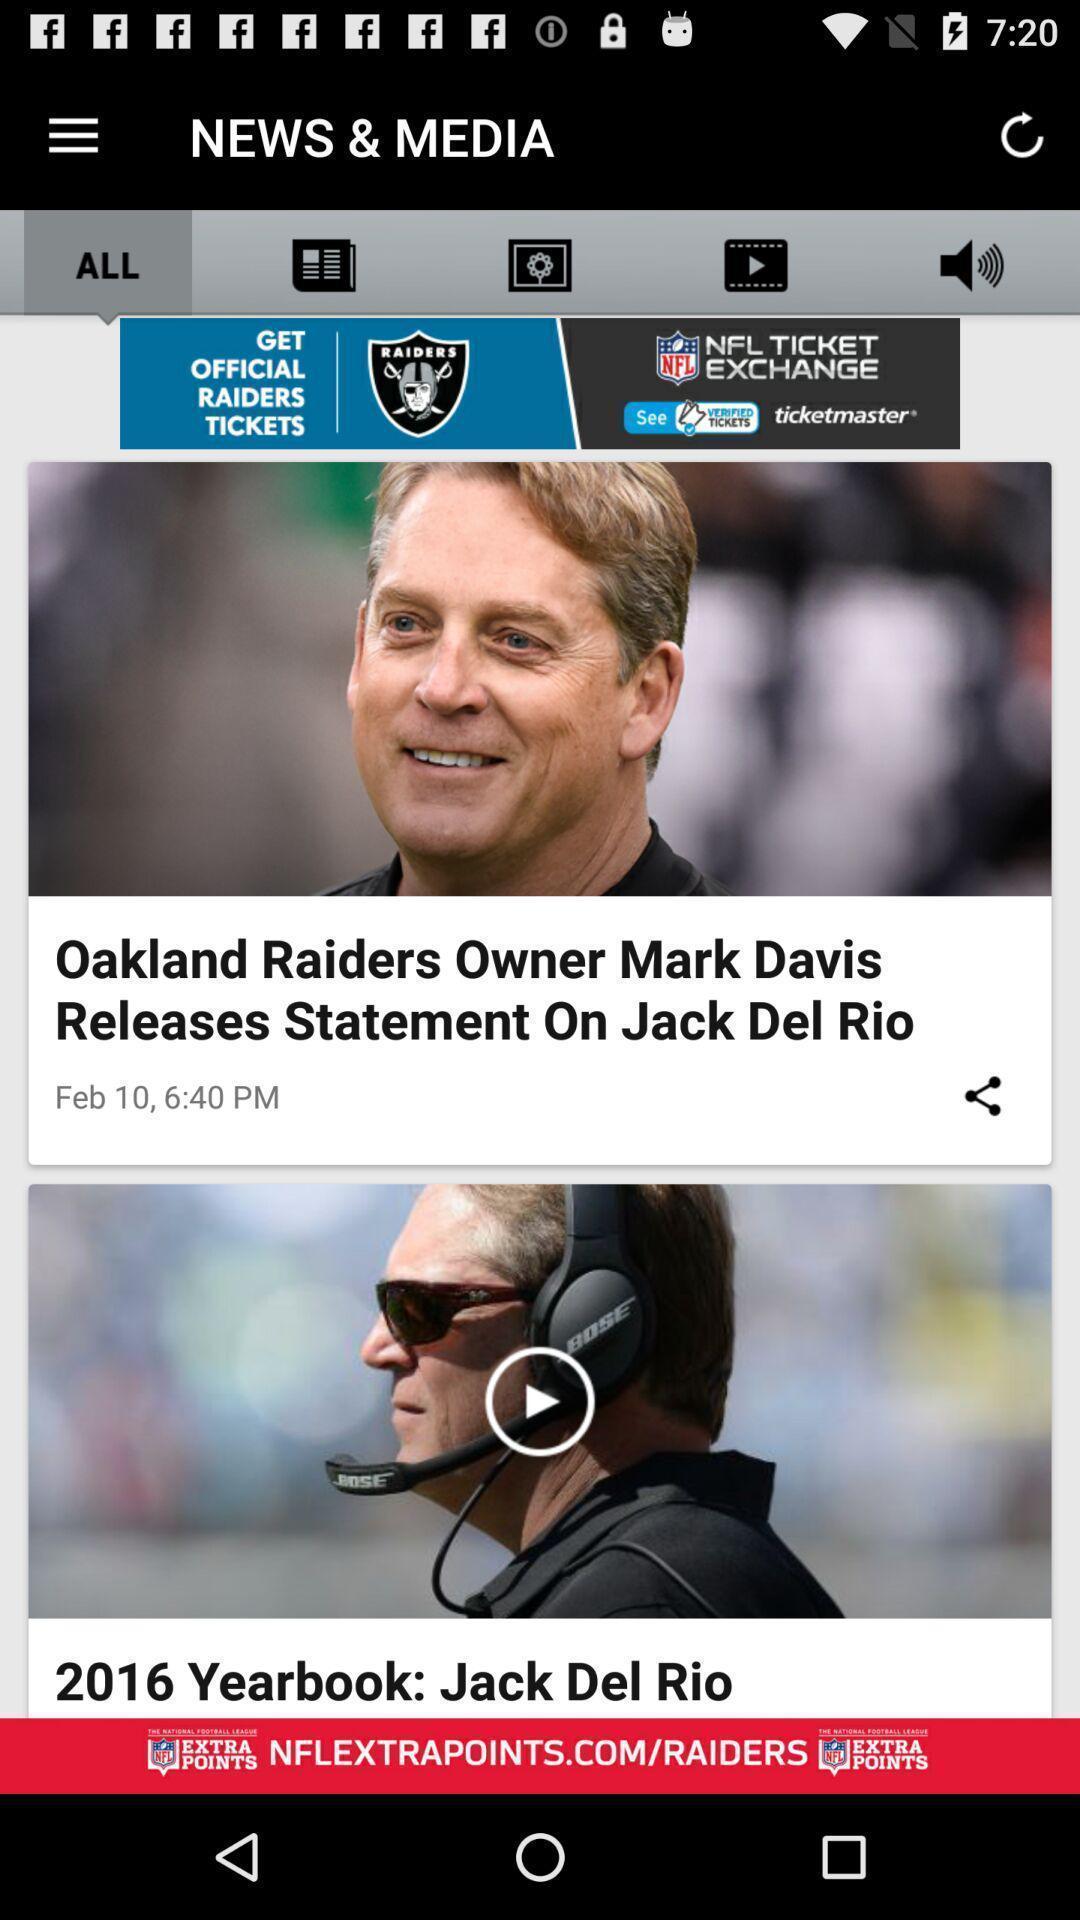What can you discern from this picture? Screen shows latest news and media. 